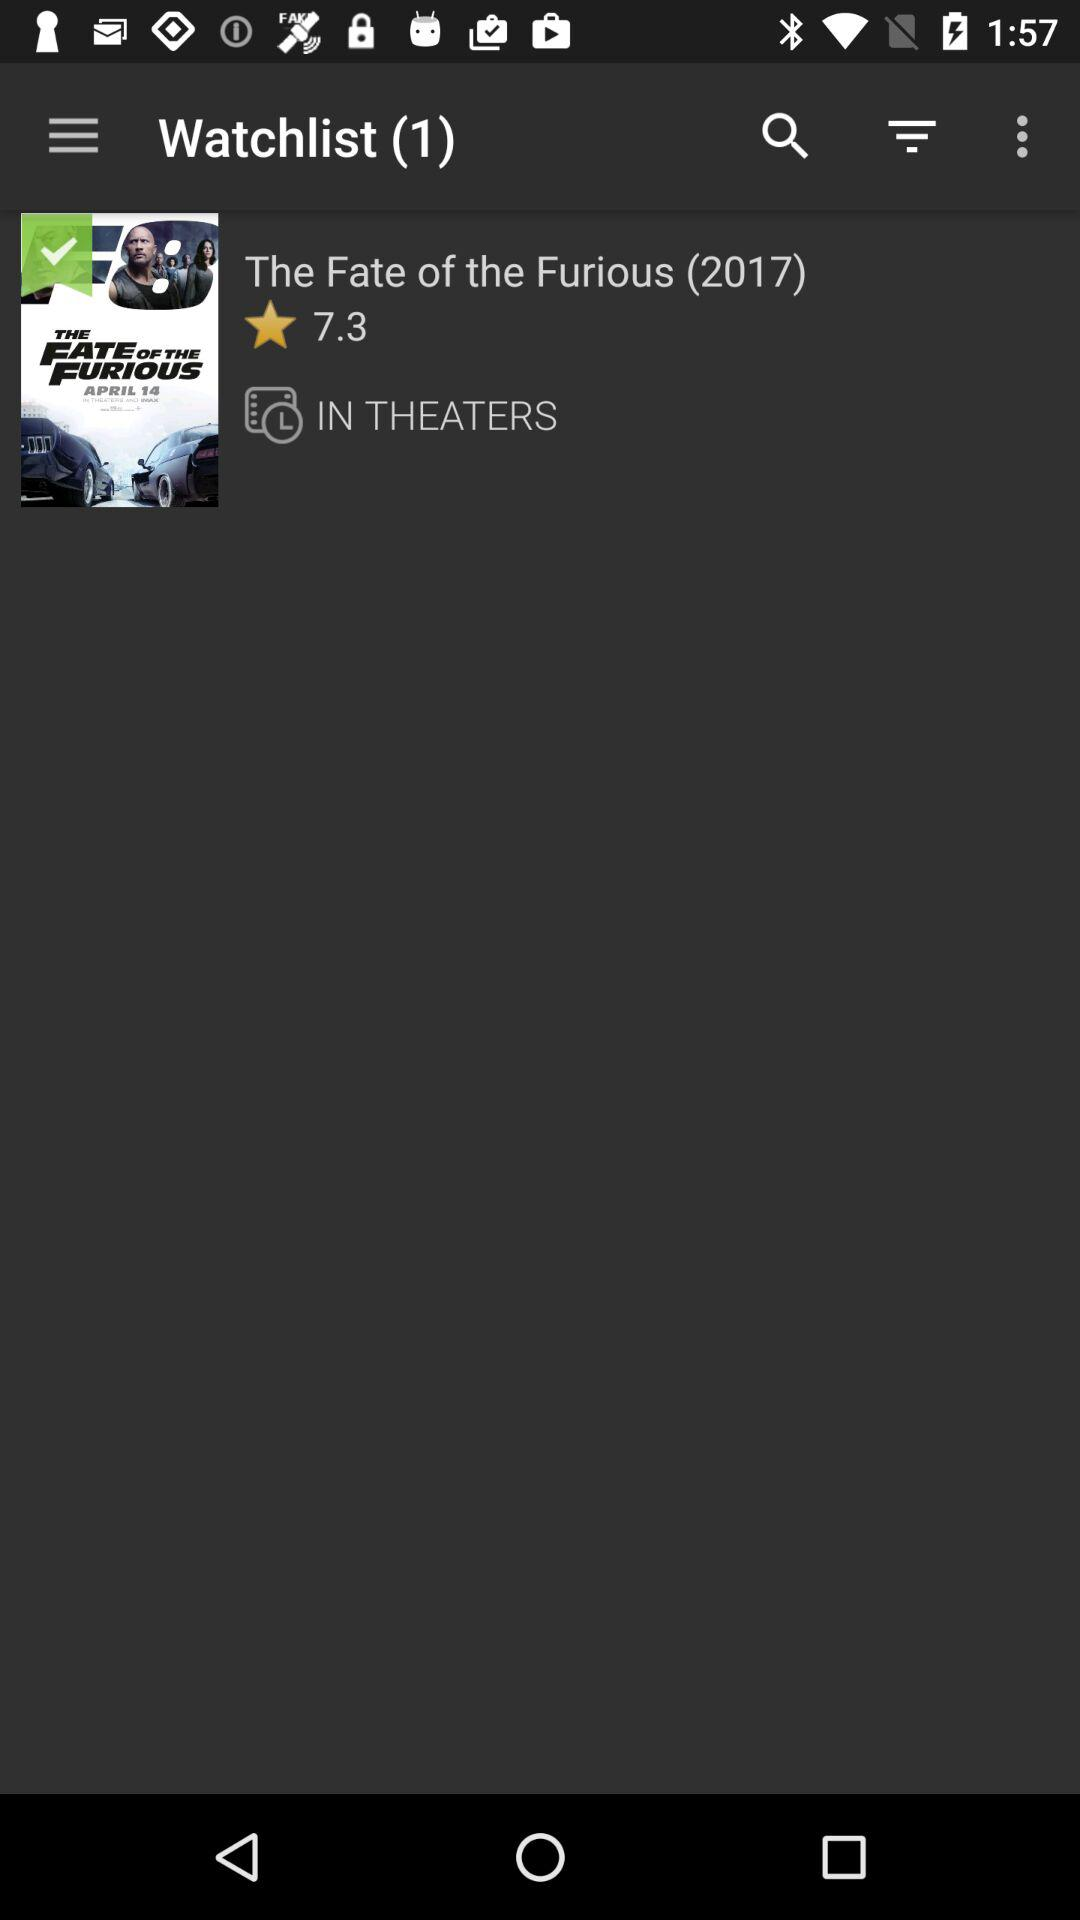What is the release year of The Fate of the Furious? The release year is 2017. 